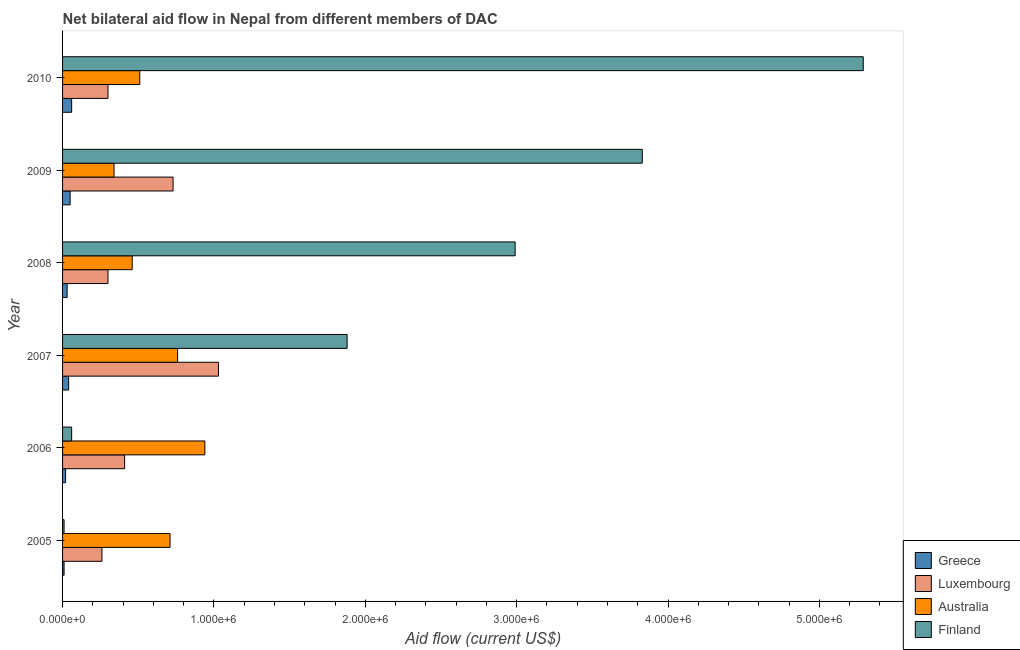How many different coloured bars are there?
Make the answer very short. 4. How many groups of bars are there?
Provide a short and direct response. 6. How many bars are there on the 3rd tick from the top?
Keep it short and to the point. 4. What is the amount of aid given by luxembourg in 2008?
Ensure brevity in your answer.  3.00e+05. Across all years, what is the maximum amount of aid given by greece?
Keep it short and to the point. 6.00e+04. Across all years, what is the minimum amount of aid given by greece?
Your response must be concise. 10000. In which year was the amount of aid given by finland maximum?
Offer a terse response. 2010. In which year was the amount of aid given by luxembourg minimum?
Your answer should be very brief. 2005. What is the total amount of aid given by australia in the graph?
Provide a short and direct response. 3.72e+06. What is the difference between the amount of aid given by greece in 2006 and that in 2008?
Keep it short and to the point. -10000. What is the difference between the amount of aid given by greece in 2005 and the amount of aid given by finland in 2006?
Offer a very short reply. -5.00e+04. What is the average amount of aid given by australia per year?
Make the answer very short. 6.20e+05. In the year 2008, what is the difference between the amount of aid given by greece and amount of aid given by australia?
Your answer should be compact. -4.30e+05. What is the ratio of the amount of aid given by finland in 2006 to that in 2008?
Your response must be concise. 0.02. What is the difference between the highest and the lowest amount of aid given by australia?
Your answer should be compact. 6.00e+05. In how many years, is the amount of aid given by finland greater than the average amount of aid given by finland taken over all years?
Provide a short and direct response. 3. Is it the case that in every year, the sum of the amount of aid given by australia and amount of aid given by luxembourg is greater than the sum of amount of aid given by greece and amount of aid given by finland?
Ensure brevity in your answer.  No. What does the 3rd bar from the top in 2006 represents?
Provide a short and direct response. Luxembourg. What does the 2nd bar from the bottom in 2010 represents?
Ensure brevity in your answer.  Luxembourg. Are all the bars in the graph horizontal?
Ensure brevity in your answer.  Yes. How many years are there in the graph?
Offer a terse response. 6. What is the difference between two consecutive major ticks on the X-axis?
Offer a terse response. 1.00e+06. Does the graph contain any zero values?
Your answer should be compact. No. Does the graph contain grids?
Offer a very short reply. No. Where does the legend appear in the graph?
Your answer should be compact. Bottom right. How many legend labels are there?
Provide a short and direct response. 4. What is the title of the graph?
Ensure brevity in your answer.  Net bilateral aid flow in Nepal from different members of DAC. Does "International Monetary Fund" appear as one of the legend labels in the graph?
Offer a very short reply. No. What is the label or title of the X-axis?
Provide a succinct answer. Aid flow (current US$). What is the label or title of the Y-axis?
Provide a short and direct response. Year. What is the Aid flow (current US$) in Greece in 2005?
Offer a very short reply. 10000. What is the Aid flow (current US$) of Luxembourg in 2005?
Your answer should be compact. 2.60e+05. What is the Aid flow (current US$) of Australia in 2005?
Provide a short and direct response. 7.10e+05. What is the Aid flow (current US$) of Australia in 2006?
Your answer should be compact. 9.40e+05. What is the Aid flow (current US$) in Greece in 2007?
Give a very brief answer. 4.00e+04. What is the Aid flow (current US$) in Luxembourg in 2007?
Ensure brevity in your answer.  1.03e+06. What is the Aid flow (current US$) of Australia in 2007?
Provide a short and direct response. 7.60e+05. What is the Aid flow (current US$) of Finland in 2007?
Offer a terse response. 1.88e+06. What is the Aid flow (current US$) of Greece in 2008?
Your answer should be compact. 3.00e+04. What is the Aid flow (current US$) in Australia in 2008?
Your answer should be very brief. 4.60e+05. What is the Aid flow (current US$) of Finland in 2008?
Provide a succinct answer. 2.99e+06. What is the Aid flow (current US$) of Luxembourg in 2009?
Ensure brevity in your answer.  7.30e+05. What is the Aid flow (current US$) in Australia in 2009?
Offer a terse response. 3.40e+05. What is the Aid flow (current US$) of Finland in 2009?
Keep it short and to the point. 3.83e+06. What is the Aid flow (current US$) in Luxembourg in 2010?
Ensure brevity in your answer.  3.00e+05. What is the Aid flow (current US$) of Australia in 2010?
Keep it short and to the point. 5.10e+05. What is the Aid flow (current US$) in Finland in 2010?
Offer a very short reply. 5.29e+06. Across all years, what is the maximum Aid flow (current US$) in Luxembourg?
Give a very brief answer. 1.03e+06. Across all years, what is the maximum Aid flow (current US$) of Australia?
Your answer should be very brief. 9.40e+05. Across all years, what is the maximum Aid flow (current US$) in Finland?
Keep it short and to the point. 5.29e+06. Across all years, what is the minimum Aid flow (current US$) in Greece?
Ensure brevity in your answer.  10000. Across all years, what is the minimum Aid flow (current US$) of Luxembourg?
Keep it short and to the point. 2.60e+05. Across all years, what is the minimum Aid flow (current US$) in Finland?
Ensure brevity in your answer.  10000. What is the total Aid flow (current US$) in Greece in the graph?
Your response must be concise. 2.10e+05. What is the total Aid flow (current US$) of Luxembourg in the graph?
Ensure brevity in your answer.  3.03e+06. What is the total Aid flow (current US$) of Australia in the graph?
Provide a short and direct response. 3.72e+06. What is the total Aid flow (current US$) in Finland in the graph?
Keep it short and to the point. 1.41e+07. What is the difference between the Aid flow (current US$) of Australia in 2005 and that in 2006?
Give a very brief answer. -2.30e+05. What is the difference between the Aid flow (current US$) in Finland in 2005 and that in 2006?
Give a very brief answer. -5.00e+04. What is the difference between the Aid flow (current US$) of Greece in 2005 and that in 2007?
Your response must be concise. -3.00e+04. What is the difference between the Aid flow (current US$) in Luxembourg in 2005 and that in 2007?
Give a very brief answer. -7.70e+05. What is the difference between the Aid flow (current US$) of Australia in 2005 and that in 2007?
Your answer should be compact. -5.00e+04. What is the difference between the Aid flow (current US$) in Finland in 2005 and that in 2007?
Ensure brevity in your answer.  -1.87e+06. What is the difference between the Aid flow (current US$) of Greece in 2005 and that in 2008?
Ensure brevity in your answer.  -2.00e+04. What is the difference between the Aid flow (current US$) in Australia in 2005 and that in 2008?
Ensure brevity in your answer.  2.50e+05. What is the difference between the Aid flow (current US$) of Finland in 2005 and that in 2008?
Provide a succinct answer. -2.98e+06. What is the difference between the Aid flow (current US$) of Greece in 2005 and that in 2009?
Ensure brevity in your answer.  -4.00e+04. What is the difference between the Aid flow (current US$) of Luxembourg in 2005 and that in 2009?
Provide a succinct answer. -4.70e+05. What is the difference between the Aid flow (current US$) in Finland in 2005 and that in 2009?
Make the answer very short. -3.82e+06. What is the difference between the Aid flow (current US$) in Greece in 2005 and that in 2010?
Keep it short and to the point. -5.00e+04. What is the difference between the Aid flow (current US$) in Luxembourg in 2005 and that in 2010?
Offer a terse response. -4.00e+04. What is the difference between the Aid flow (current US$) in Australia in 2005 and that in 2010?
Ensure brevity in your answer.  2.00e+05. What is the difference between the Aid flow (current US$) in Finland in 2005 and that in 2010?
Keep it short and to the point. -5.28e+06. What is the difference between the Aid flow (current US$) of Greece in 2006 and that in 2007?
Keep it short and to the point. -2.00e+04. What is the difference between the Aid flow (current US$) in Luxembourg in 2006 and that in 2007?
Your response must be concise. -6.20e+05. What is the difference between the Aid flow (current US$) of Australia in 2006 and that in 2007?
Keep it short and to the point. 1.80e+05. What is the difference between the Aid flow (current US$) in Finland in 2006 and that in 2007?
Your answer should be compact. -1.82e+06. What is the difference between the Aid flow (current US$) in Finland in 2006 and that in 2008?
Offer a terse response. -2.93e+06. What is the difference between the Aid flow (current US$) of Greece in 2006 and that in 2009?
Offer a very short reply. -3.00e+04. What is the difference between the Aid flow (current US$) of Luxembourg in 2006 and that in 2009?
Your response must be concise. -3.20e+05. What is the difference between the Aid flow (current US$) in Finland in 2006 and that in 2009?
Keep it short and to the point. -3.77e+06. What is the difference between the Aid flow (current US$) of Luxembourg in 2006 and that in 2010?
Provide a succinct answer. 1.10e+05. What is the difference between the Aid flow (current US$) in Australia in 2006 and that in 2010?
Keep it short and to the point. 4.30e+05. What is the difference between the Aid flow (current US$) in Finland in 2006 and that in 2010?
Your answer should be compact. -5.23e+06. What is the difference between the Aid flow (current US$) in Luxembourg in 2007 and that in 2008?
Keep it short and to the point. 7.30e+05. What is the difference between the Aid flow (current US$) of Australia in 2007 and that in 2008?
Your answer should be very brief. 3.00e+05. What is the difference between the Aid flow (current US$) of Finland in 2007 and that in 2008?
Give a very brief answer. -1.11e+06. What is the difference between the Aid flow (current US$) in Greece in 2007 and that in 2009?
Provide a succinct answer. -10000. What is the difference between the Aid flow (current US$) in Luxembourg in 2007 and that in 2009?
Offer a terse response. 3.00e+05. What is the difference between the Aid flow (current US$) in Finland in 2007 and that in 2009?
Offer a terse response. -1.95e+06. What is the difference between the Aid flow (current US$) in Greece in 2007 and that in 2010?
Make the answer very short. -2.00e+04. What is the difference between the Aid flow (current US$) of Luxembourg in 2007 and that in 2010?
Provide a succinct answer. 7.30e+05. What is the difference between the Aid flow (current US$) in Australia in 2007 and that in 2010?
Your answer should be very brief. 2.50e+05. What is the difference between the Aid flow (current US$) in Finland in 2007 and that in 2010?
Make the answer very short. -3.41e+06. What is the difference between the Aid flow (current US$) of Greece in 2008 and that in 2009?
Ensure brevity in your answer.  -2.00e+04. What is the difference between the Aid flow (current US$) in Luxembourg in 2008 and that in 2009?
Ensure brevity in your answer.  -4.30e+05. What is the difference between the Aid flow (current US$) in Australia in 2008 and that in 2009?
Your answer should be very brief. 1.20e+05. What is the difference between the Aid flow (current US$) of Finland in 2008 and that in 2009?
Offer a very short reply. -8.40e+05. What is the difference between the Aid flow (current US$) of Greece in 2008 and that in 2010?
Offer a terse response. -3.00e+04. What is the difference between the Aid flow (current US$) in Luxembourg in 2008 and that in 2010?
Make the answer very short. 0. What is the difference between the Aid flow (current US$) in Finland in 2008 and that in 2010?
Your answer should be compact. -2.30e+06. What is the difference between the Aid flow (current US$) in Luxembourg in 2009 and that in 2010?
Ensure brevity in your answer.  4.30e+05. What is the difference between the Aid flow (current US$) in Australia in 2009 and that in 2010?
Your response must be concise. -1.70e+05. What is the difference between the Aid flow (current US$) in Finland in 2009 and that in 2010?
Your answer should be very brief. -1.46e+06. What is the difference between the Aid flow (current US$) in Greece in 2005 and the Aid flow (current US$) in Luxembourg in 2006?
Provide a short and direct response. -4.00e+05. What is the difference between the Aid flow (current US$) of Greece in 2005 and the Aid flow (current US$) of Australia in 2006?
Give a very brief answer. -9.30e+05. What is the difference between the Aid flow (current US$) of Luxembourg in 2005 and the Aid flow (current US$) of Australia in 2006?
Keep it short and to the point. -6.80e+05. What is the difference between the Aid flow (current US$) in Australia in 2005 and the Aid flow (current US$) in Finland in 2006?
Keep it short and to the point. 6.50e+05. What is the difference between the Aid flow (current US$) of Greece in 2005 and the Aid flow (current US$) of Luxembourg in 2007?
Ensure brevity in your answer.  -1.02e+06. What is the difference between the Aid flow (current US$) in Greece in 2005 and the Aid flow (current US$) in Australia in 2007?
Offer a very short reply. -7.50e+05. What is the difference between the Aid flow (current US$) in Greece in 2005 and the Aid flow (current US$) in Finland in 2007?
Provide a short and direct response. -1.87e+06. What is the difference between the Aid flow (current US$) in Luxembourg in 2005 and the Aid flow (current US$) in Australia in 2007?
Your answer should be compact. -5.00e+05. What is the difference between the Aid flow (current US$) in Luxembourg in 2005 and the Aid flow (current US$) in Finland in 2007?
Offer a terse response. -1.62e+06. What is the difference between the Aid flow (current US$) of Australia in 2005 and the Aid flow (current US$) of Finland in 2007?
Provide a short and direct response. -1.17e+06. What is the difference between the Aid flow (current US$) in Greece in 2005 and the Aid flow (current US$) in Australia in 2008?
Offer a terse response. -4.50e+05. What is the difference between the Aid flow (current US$) of Greece in 2005 and the Aid flow (current US$) of Finland in 2008?
Keep it short and to the point. -2.98e+06. What is the difference between the Aid flow (current US$) in Luxembourg in 2005 and the Aid flow (current US$) in Australia in 2008?
Keep it short and to the point. -2.00e+05. What is the difference between the Aid flow (current US$) in Luxembourg in 2005 and the Aid flow (current US$) in Finland in 2008?
Offer a very short reply. -2.73e+06. What is the difference between the Aid flow (current US$) of Australia in 2005 and the Aid flow (current US$) of Finland in 2008?
Give a very brief answer. -2.28e+06. What is the difference between the Aid flow (current US$) of Greece in 2005 and the Aid flow (current US$) of Luxembourg in 2009?
Your response must be concise. -7.20e+05. What is the difference between the Aid flow (current US$) in Greece in 2005 and the Aid flow (current US$) in Australia in 2009?
Offer a terse response. -3.30e+05. What is the difference between the Aid flow (current US$) in Greece in 2005 and the Aid flow (current US$) in Finland in 2009?
Provide a short and direct response. -3.82e+06. What is the difference between the Aid flow (current US$) of Luxembourg in 2005 and the Aid flow (current US$) of Finland in 2009?
Ensure brevity in your answer.  -3.57e+06. What is the difference between the Aid flow (current US$) of Australia in 2005 and the Aid flow (current US$) of Finland in 2009?
Give a very brief answer. -3.12e+06. What is the difference between the Aid flow (current US$) of Greece in 2005 and the Aid flow (current US$) of Australia in 2010?
Provide a succinct answer. -5.00e+05. What is the difference between the Aid flow (current US$) of Greece in 2005 and the Aid flow (current US$) of Finland in 2010?
Offer a very short reply. -5.28e+06. What is the difference between the Aid flow (current US$) of Luxembourg in 2005 and the Aid flow (current US$) of Australia in 2010?
Give a very brief answer. -2.50e+05. What is the difference between the Aid flow (current US$) of Luxembourg in 2005 and the Aid flow (current US$) of Finland in 2010?
Keep it short and to the point. -5.03e+06. What is the difference between the Aid flow (current US$) in Australia in 2005 and the Aid flow (current US$) in Finland in 2010?
Keep it short and to the point. -4.58e+06. What is the difference between the Aid flow (current US$) in Greece in 2006 and the Aid flow (current US$) in Luxembourg in 2007?
Provide a short and direct response. -1.01e+06. What is the difference between the Aid flow (current US$) in Greece in 2006 and the Aid flow (current US$) in Australia in 2007?
Keep it short and to the point. -7.40e+05. What is the difference between the Aid flow (current US$) in Greece in 2006 and the Aid flow (current US$) in Finland in 2007?
Provide a short and direct response. -1.86e+06. What is the difference between the Aid flow (current US$) of Luxembourg in 2006 and the Aid flow (current US$) of Australia in 2007?
Offer a very short reply. -3.50e+05. What is the difference between the Aid flow (current US$) of Luxembourg in 2006 and the Aid flow (current US$) of Finland in 2007?
Your answer should be very brief. -1.47e+06. What is the difference between the Aid flow (current US$) in Australia in 2006 and the Aid flow (current US$) in Finland in 2007?
Offer a very short reply. -9.40e+05. What is the difference between the Aid flow (current US$) in Greece in 2006 and the Aid flow (current US$) in Luxembourg in 2008?
Keep it short and to the point. -2.80e+05. What is the difference between the Aid flow (current US$) of Greece in 2006 and the Aid flow (current US$) of Australia in 2008?
Offer a very short reply. -4.40e+05. What is the difference between the Aid flow (current US$) of Greece in 2006 and the Aid flow (current US$) of Finland in 2008?
Make the answer very short. -2.97e+06. What is the difference between the Aid flow (current US$) in Luxembourg in 2006 and the Aid flow (current US$) in Australia in 2008?
Ensure brevity in your answer.  -5.00e+04. What is the difference between the Aid flow (current US$) in Luxembourg in 2006 and the Aid flow (current US$) in Finland in 2008?
Make the answer very short. -2.58e+06. What is the difference between the Aid flow (current US$) in Australia in 2006 and the Aid flow (current US$) in Finland in 2008?
Provide a succinct answer. -2.05e+06. What is the difference between the Aid flow (current US$) in Greece in 2006 and the Aid flow (current US$) in Luxembourg in 2009?
Keep it short and to the point. -7.10e+05. What is the difference between the Aid flow (current US$) in Greece in 2006 and the Aid flow (current US$) in Australia in 2009?
Make the answer very short. -3.20e+05. What is the difference between the Aid flow (current US$) of Greece in 2006 and the Aid flow (current US$) of Finland in 2009?
Keep it short and to the point. -3.81e+06. What is the difference between the Aid flow (current US$) of Luxembourg in 2006 and the Aid flow (current US$) of Finland in 2009?
Give a very brief answer. -3.42e+06. What is the difference between the Aid flow (current US$) in Australia in 2006 and the Aid flow (current US$) in Finland in 2009?
Provide a short and direct response. -2.89e+06. What is the difference between the Aid flow (current US$) of Greece in 2006 and the Aid flow (current US$) of Luxembourg in 2010?
Provide a short and direct response. -2.80e+05. What is the difference between the Aid flow (current US$) of Greece in 2006 and the Aid flow (current US$) of Australia in 2010?
Your answer should be very brief. -4.90e+05. What is the difference between the Aid flow (current US$) in Greece in 2006 and the Aid flow (current US$) in Finland in 2010?
Make the answer very short. -5.27e+06. What is the difference between the Aid flow (current US$) in Luxembourg in 2006 and the Aid flow (current US$) in Finland in 2010?
Give a very brief answer. -4.88e+06. What is the difference between the Aid flow (current US$) of Australia in 2006 and the Aid flow (current US$) of Finland in 2010?
Provide a succinct answer. -4.35e+06. What is the difference between the Aid flow (current US$) of Greece in 2007 and the Aid flow (current US$) of Luxembourg in 2008?
Offer a very short reply. -2.60e+05. What is the difference between the Aid flow (current US$) in Greece in 2007 and the Aid flow (current US$) in Australia in 2008?
Provide a short and direct response. -4.20e+05. What is the difference between the Aid flow (current US$) in Greece in 2007 and the Aid flow (current US$) in Finland in 2008?
Ensure brevity in your answer.  -2.95e+06. What is the difference between the Aid flow (current US$) of Luxembourg in 2007 and the Aid flow (current US$) of Australia in 2008?
Offer a terse response. 5.70e+05. What is the difference between the Aid flow (current US$) in Luxembourg in 2007 and the Aid flow (current US$) in Finland in 2008?
Provide a succinct answer. -1.96e+06. What is the difference between the Aid flow (current US$) of Australia in 2007 and the Aid flow (current US$) of Finland in 2008?
Give a very brief answer. -2.23e+06. What is the difference between the Aid flow (current US$) in Greece in 2007 and the Aid flow (current US$) in Luxembourg in 2009?
Offer a terse response. -6.90e+05. What is the difference between the Aid flow (current US$) of Greece in 2007 and the Aid flow (current US$) of Finland in 2009?
Keep it short and to the point. -3.79e+06. What is the difference between the Aid flow (current US$) of Luxembourg in 2007 and the Aid flow (current US$) of Australia in 2009?
Your response must be concise. 6.90e+05. What is the difference between the Aid flow (current US$) of Luxembourg in 2007 and the Aid flow (current US$) of Finland in 2009?
Ensure brevity in your answer.  -2.80e+06. What is the difference between the Aid flow (current US$) in Australia in 2007 and the Aid flow (current US$) in Finland in 2009?
Offer a very short reply. -3.07e+06. What is the difference between the Aid flow (current US$) in Greece in 2007 and the Aid flow (current US$) in Australia in 2010?
Provide a succinct answer. -4.70e+05. What is the difference between the Aid flow (current US$) in Greece in 2007 and the Aid flow (current US$) in Finland in 2010?
Make the answer very short. -5.25e+06. What is the difference between the Aid flow (current US$) in Luxembourg in 2007 and the Aid flow (current US$) in Australia in 2010?
Make the answer very short. 5.20e+05. What is the difference between the Aid flow (current US$) in Luxembourg in 2007 and the Aid flow (current US$) in Finland in 2010?
Offer a very short reply. -4.26e+06. What is the difference between the Aid flow (current US$) of Australia in 2007 and the Aid flow (current US$) of Finland in 2010?
Your answer should be compact. -4.53e+06. What is the difference between the Aid flow (current US$) in Greece in 2008 and the Aid flow (current US$) in Luxembourg in 2009?
Ensure brevity in your answer.  -7.00e+05. What is the difference between the Aid flow (current US$) of Greece in 2008 and the Aid flow (current US$) of Australia in 2009?
Your answer should be compact. -3.10e+05. What is the difference between the Aid flow (current US$) in Greece in 2008 and the Aid flow (current US$) in Finland in 2009?
Provide a succinct answer. -3.80e+06. What is the difference between the Aid flow (current US$) in Luxembourg in 2008 and the Aid flow (current US$) in Finland in 2009?
Give a very brief answer. -3.53e+06. What is the difference between the Aid flow (current US$) of Australia in 2008 and the Aid flow (current US$) of Finland in 2009?
Offer a terse response. -3.37e+06. What is the difference between the Aid flow (current US$) in Greece in 2008 and the Aid flow (current US$) in Luxembourg in 2010?
Make the answer very short. -2.70e+05. What is the difference between the Aid flow (current US$) of Greece in 2008 and the Aid flow (current US$) of Australia in 2010?
Ensure brevity in your answer.  -4.80e+05. What is the difference between the Aid flow (current US$) in Greece in 2008 and the Aid flow (current US$) in Finland in 2010?
Ensure brevity in your answer.  -5.26e+06. What is the difference between the Aid flow (current US$) of Luxembourg in 2008 and the Aid flow (current US$) of Australia in 2010?
Give a very brief answer. -2.10e+05. What is the difference between the Aid flow (current US$) in Luxembourg in 2008 and the Aid flow (current US$) in Finland in 2010?
Give a very brief answer. -4.99e+06. What is the difference between the Aid flow (current US$) of Australia in 2008 and the Aid flow (current US$) of Finland in 2010?
Provide a short and direct response. -4.83e+06. What is the difference between the Aid flow (current US$) of Greece in 2009 and the Aid flow (current US$) of Australia in 2010?
Provide a short and direct response. -4.60e+05. What is the difference between the Aid flow (current US$) in Greece in 2009 and the Aid flow (current US$) in Finland in 2010?
Give a very brief answer. -5.24e+06. What is the difference between the Aid flow (current US$) of Luxembourg in 2009 and the Aid flow (current US$) of Australia in 2010?
Make the answer very short. 2.20e+05. What is the difference between the Aid flow (current US$) of Luxembourg in 2009 and the Aid flow (current US$) of Finland in 2010?
Make the answer very short. -4.56e+06. What is the difference between the Aid flow (current US$) of Australia in 2009 and the Aid flow (current US$) of Finland in 2010?
Provide a short and direct response. -4.95e+06. What is the average Aid flow (current US$) of Greece per year?
Your answer should be very brief. 3.50e+04. What is the average Aid flow (current US$) in Luxembourg per year?
Ensure brevity in your answer.  5.05e+05. What is the average Aid flow (current US$) in Australia per year?
Provide a succinct answer. 6.20e+05. What is the average Aid flow (current US$) in Finland per year?
Keep it short and to the point. 2.34e+06. In the year 2005, what is the difference between the Aid flow (current US$) of Greece and Aid flow (current US$) of Australia?
Ensure brevity in your answer.  -7.00e+05. In the year 2005, what is the difference between the Aid flow (current US$) in Luxembourg and Aid flow (current US$) in Australia?
Your answer should be compact. -4.50e+05. In the year 2005, what is the difference between the Aid flow (current US$) in Australia and Aid flow (current US$) in Finland?
Your answer should be very brief. 7.00e+05. In the year 2006, what is the difference between the Aid flow (current US$) of Greece and Aid flow (current US$) of Luxembourg?
Offer a very short reply. -3.90e+05. In the year 2006, what is the difference between the Aid flow (current US$) in Greece and Aid flow (current US$) in Australia?
Provide a short and direct response. -9.20e+05. In the year 2006, what is the difference between the Aid flow (current US$) of Luxembourg and Aid flow (current US$) of Australia?
Give a very brief answer. -5.30e+05. In the year 2006, what is the difference between the Aid flow (current US$) in Australia and Aid flow (current US$) in Finland?
Provide a succinct answer. 8.80e+05. In the year 2007, what is the difference between the Aid flow (current US$) of Greece and Aid flow (current US$) of Luxembourg?
Your response must be concise. -9.90e+05. In the year 2007, what is the difference between the Aid flow (current US$) in Greece and Aid flow (current US$) in Australia?
Your response must be concise. -7.20e+05. In the year 2007, what is the difference between the Aid flow (current US$) of Greece and Aid flow (current US$) of Finland?
Give a very brief answer. -1.84e+06. In the year 2007, what is the difference between the Aid flow (current US$) of Luxembourg and Aid flow (current US$) of Finland?
Offer a very short reply. -8.50e+05. In the year 2007, what is the difference between the Aid flow (current US$) in Australia and Aid flow (current US$) in Finland?
Ensure brevity in your answer.  -1.12e+06. In the year 2008, what is the difference between the Aid flow (current US$) of Greece and Aid flow (current US$) of Australia?
Offer a terse response. -4.30e+05. In the year 2008, what is the difference between the Aid flow (current US$) of Greece and Aid flow (current US$) of Finland?
Provide a succinct answer. -2.96e+06. In the year 2008, what is the difference between the Aid flow (current US$) of Luxembourg and Aid flow (current US$) of Australia?
Your response must be concise. -1.60e+05. In the year 2008, what is the difference between the Aid flow (current US$) in Luxembourg and Aid flow (current US$) in Finland?
Offer a terse response. -2.69e+06. In the year 2008, what is the difference between the Aid flow (current US$) of Australia and Aid flow (current US$) of Finland?
Your response must be concise. -2.53e+06. In the year 2009, what is the difference between the Aid flow (current US$) of Greece and Aid flow (current US$) of Luxembourg?
Provide a short and direct response. -6.80e+05. In the year 2009, what is the difference between the Aid flow (current US$) in Greece and Aid flow (current US$) in Finland?
Offer a terse response. -3.78e+06. In the year 2009, what is the difference between the Aid flow (current US$) in Luxembourg and Aid flow (current US$) in Finland?
Ensure brevity in your answer.  -3.10e+06. In the year 2009, what is the difference between the Aid flow (current US$) of Australia and Aid flow (current US$) of Finland?
Make the answer very short. -3.49e+06. In the year 2010, what is the difference between the Aid flow (current US$) of Greece and Aid flow (current US$) of Luxembourg?
Your response must be concise. -2.40e+05. In the year 2010, what is the difference between the Aid flow (current US$) in Greece and Aid flow (current US$) in Australia?
Your answer should be very brief. -4.50e+05. In the year 2010, what is the difference between the Aid flow (current US$) of Greece and Aid flow (current US$) of Finland?
Your response must be concise. -5.23e+06. In the year 2010, what is the difference between the Aid flow (current US$) in Luxembourg and Aid flow (current US$) in Australia?
Keep it short and to the point. -2.10e+05. In the year 2010, what is the difference between the Aid flow (current US$) in Luxembourg and Aid flow (current US$) in Finland?
Your answer should be very brief. -4.99e+06. In the year 2010, what is the difference between the Aid flow (current US$) in Australia and Aid flow (current US$) in Finland?
Your answer should be very brief. -4.78e+06. What is the ratio of the Aid flow (current US$) of Luxembourg in 2005 to that in 2006?
Your answer should be compact. 0.63. What is the ratio of the Aid flow (current US$) of Australia in 2005 to that in 2006?
Keep it short and to the point. 0.76. What is the ratio of the Aid flow (current US$) of Finland in 2005 to that in 2006?
Offer a terse response. 0.17. What is the ratio of the Aid flow (current US$) of Greece in 2005 to that in 2007?
Offer a terse response. 0.25. What is the ratio of the Aid flow (current US$) of Luxembourg in 2005 to that in 2007?
Make the answer very short. 0.25. What is the ratio of the Aid flow (current US$) of Australia in 2005 to that in 2007?
Offer a very short reply. 0.93. What is the ratio of the Aid flow (current US$) in Finland in 2005 to that in 2007?
Provide a succinct answer. 0.01. What is the ratio of the Aid flow (current US$) in Luxembourg in 2005 to that in 2008?
Your answer should be compact. 0.87. What is the ratio of the Aid flow (current US$) in Australia in 2005 to that in 2008?
Make the answer very short. 1.54. What is the ratio of the Aid flow (current US$) of Finland in 2005 to that in 2008?
Provide a succinct answer. 0. What is the ratio of the Aid flow (current US$) in Luxembourg in 2005 to that in 2009?
Offer a terse response. 0.36. What is the ratio of the Aid flow (current US$) in Australia in 2005 to that in 2009?
Provide a short and direct response. 2.09. What is the ratio of the Aid flow (current US$) in Finland in 2005 to that in 2009?
Offer a terse response. 0. What is the ratio of the Aid flow (current US$) in Luxembourg in 2005 to that in 2010?
Your response must be concise. 0.87. What is the ratio of the Aid flow (current US$) of Australia in 2005 to that in 2010?
Offer a very short reply. 1.39. What is the ratio of the Aid flow (current US$) of Finland in 2005 to that in 2010?
Make the answer very short. 0. What is the ratio of the Aid flow (current US$) in Luxembourg in 2006 to that in 2007?
Your answer should be compact. 0.4. What is the ratio of the Aid flow (current US$) of Australia in 2006 to that in 2007?
Make the answer very short. 1.24. What is the ratio of the Aid flow (current US$) in Finland in 2006 to that in 2007?
Keep it short and to the point. 0.03. What is the ratio of the Aid flow (current US$) in Greece in 2006 to that in 2008?
Provide a short and direct response. 0.67. What is the ratio of the Aid flow (current US$) in Luxembourg in 2006 to that in 2008?
Offer a very short reply. 1.37. What is the ratio of the Aid flow (current US$) in Australia in 2006 to that in 2008?
Keep it short and to the point. 2.04. What is the ratio of the Aid flow (current US$) of Finland in 2006 to that in 2008?
Keep it short and to the point. 0.02. What is the ratio of the Aid flow (current US$) in Luxembourg in 2006 to that in 2009?
Provide a short and direct response. 0.56. What is the ratio of the Aid flow (current US$) of Australia in 2006 to that in 2009?
Provide a succinct answer. 2.76. What is the ratio of the Aid flow (current US$) of Finland in 2006 to that in 2009?
Ensure brevity in your answer.  0.02. What is the ratio of the Aid flow (current US$) of Luxembourg in 2006 to that in 2010?
Your answer should be very brief. 1.37. What is the ratio of the Aid flow (current US$) in Australia in 2006 to that in 2010?
Offer a very short reply. 1.84. What is the ratio of the Aid flow (current US$) of Finland in 2006 to that in 2010?
Your answer should be very brief. 0.01. What is the ratio of the Aid flow (current US$) of Luxembourg in 2007 to that in 2008?
Keep it short and to the point. 3.43. What is the ratio of the Aid flow (current US$) of Australia in 2007 to that in 2008?
Ensure brevity in your answer.  1.65. What is the ratio of the Aid flow (current US$) of Finland in 2007 to that in 2008?
Your answer should be very brief. 0.63. What is the ratio of the Aid flow (current US$) of Greece in 2007 to that in 2009?
Give a very brief answer. 0.8. What is the ratio of the Aid flow (current US$) in Luxembourg in 2007 to that in 2009?
Ensure brevity in your answer.  1.41. What is the ratio of the Aid flow (current US$) of Australia in 2007 to that in 2009?
Your answer should be very brief. 2.24. What is the ratio of the Aid flow (current US$) of Finland in 2007 to that in 2009?
Your answer should be compact. 0.49. What is the ratio of the Aid flow (current US$) in Luxembourg in 2007 to that in 2010?
Give a very brief answer. 3.43. What is the ratio of the Aid flow (current US$) of Australia in 2007 to that in 2010?
Provide a succinct answer. 1.49. What is the ratio of the Aid flow (current US$) in Finland in 2007 to that in 2010?
Provide a succinct answer. 0.36. What is the ratio of the Aid flow (current US$) of Luxembourg in 2008 to that in 2009?
Make the answer very short. 0.41. What is the ratio of the Aid flow (current US$) of Australia in 2008 to that in 2009?
Offer a very short reply. 1.35. What is the ratio of the Aid flow (current US$) of Finland in 2008 to that in 2009?
Your answer should be compact. 0.78. What is the ratio of the Aid flow (current US$) of Greece in 2008 to that in 2010?
Your answer should be very brief. 0.5. What is the ratio of the Aid flow (current US$) of Luxembourg in 2008 to that in 2010?
Ensure brevity in your answer.  1. What is the ratio of the Aid flow (current US$) in Australia in 2008 to that in 2010?
Offer a terse response. 0.9. What is the ratio of the Aid flow (current US$) in Finland in 2008 to that in 2010?
Provide a short and direct response. 0.57. What is the ratio of the Aid flow (current US$) of Greece in 2009 to that in 2010?
Offer a terse response. 0.83. What is the ratio of the Aid flow (current US$) of Luxembourg in 2009 to that in 2010?
Make the answer very short. 2.43. What is the ratio of the Aid flow (current US$) of Australia in 2009 to that in 2010?
Give a very brief answer. 0.67. What is the ratio of the Aid flow (current US$) of Finland in 2009 to that in 2010?
Provide a short and direct response. 0.72. What is the difference between the highest and the second highest Aid flow (current US$) in Greece?
Your answer should be compact. 10000. What is the difference between the highest and the second highest Aid flow (current US$) of Luxembourg?
Provide a short and direct response. 3.00e+05. What is the difference between the highest and the second highest Aid flow (current US$) of Finland?
Keep it short and to the point. 1.46e+06. What is the difference between the highest and the lowest Aid flow (current US$) in Luxembourg?
Your answer should be very brief. 7.70e+05. What is the difference between the highest and the lowest Aid flow (current US$) in Finland?
Provide a short and direct response. 5.28e+06. 